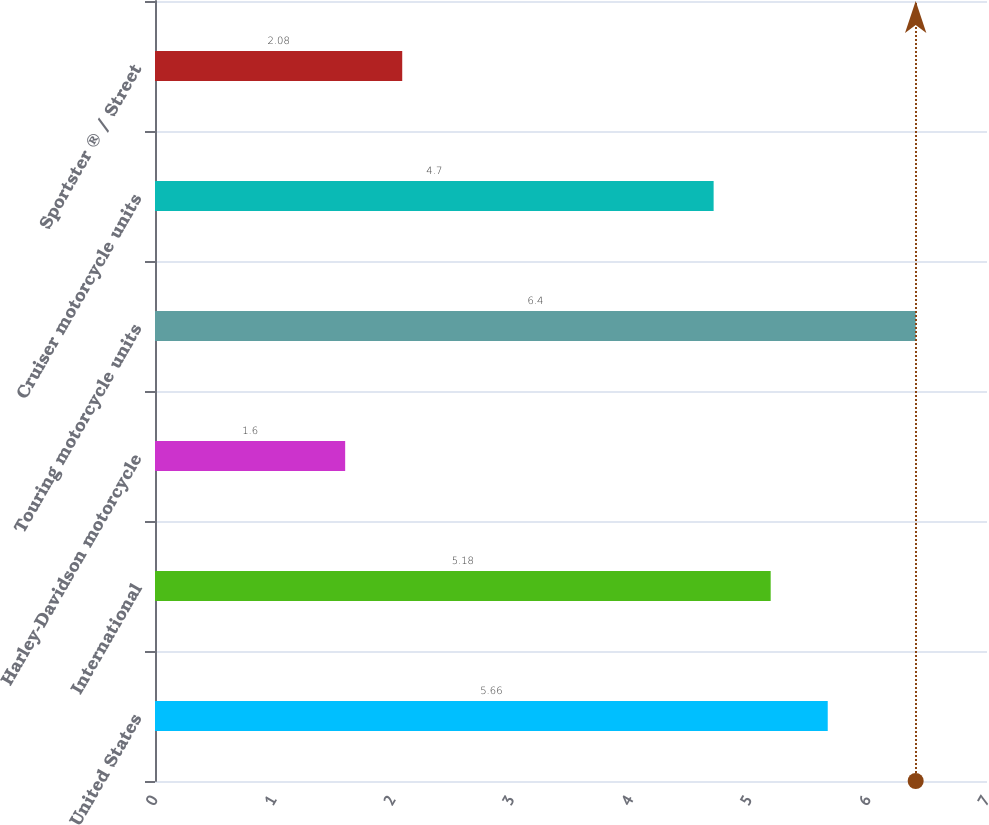<chart> <loc_0><loc_0><loc_500><loc_500><bar_chart><fcel>United States<fcel>International<fcel>Harley-Davidson motorcycle<fcel>Touring motorcycle units<fcel>Cruiser motorcycle units<fcel>Sportster ® / Street<nl><fcel>5.66<fcel>5.18<fcel>1.6<fcel>6.4<fcel>4.7<fcel>2.08<nl></chart> 